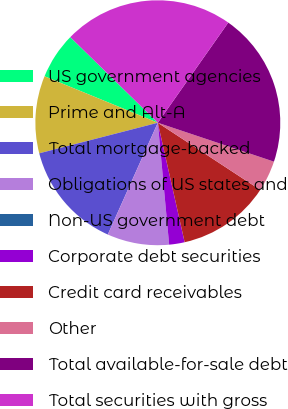<chart> <loc_0><loc_0><loc_500><loc_500><pie_chart><fcel>US government agencies<fcel>Prime and Alt-A<fcel>Total mortgage-backed<fcel>Obligations of US states and<fcel>Non-US government debt<fcel>Corporate debt securities<fcel>Credit card receivables<fcel>Other<fcel>Total available-for-sale debt<fcel>Total securities with gross<nl><fcel>6.13%<fcel>10.21%<fcel>14.29%<fcel>8.17%<fcel>0.0%<fcel>2.04%<fcel>12.25%<fcel>4.09%<fcel>20.39%<fcel>22.43%<nl></chart> 